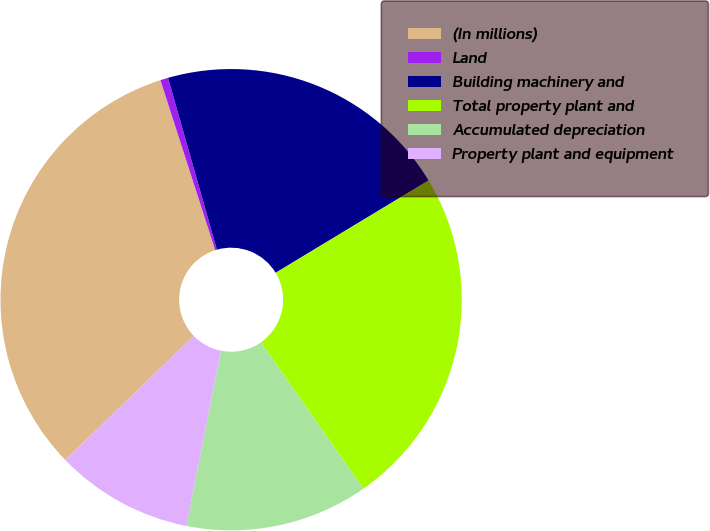<chart> <loc_0><loc_0><loc_500><loc_500><pie_chart><fcel>(In millions)<fcel>Land<fcel>Building machinery and<fcel>Total property plant and<fcel>Accumulated depreciation<fcel>Property plant and equipment<nl><fcel>32.27%<fcel>0.55%<fcel>20.76%<fcel>23.93%<fcel>12.83%<fcel>9.66%<nl></chart> 